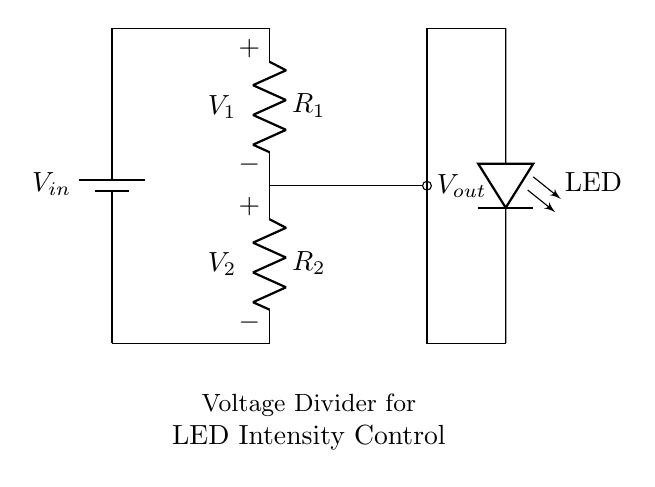What components are in the circuit? The circuit includes a battery, two resistors, and an LED. Each component serves a specific function: the battery provides power, the resistors create a voltage divider, and the LED lights up when a certain voltage is applied.
Answer: battery, two resistors, LED What is the function of the resistors? The resistors R1 and R2 in a voltage divider control the voltage output to the LED by dividing the input voltage. The ratio of their resistances determines the voltage drop across each, which in turn determines the voltage applied to the LED, controlling its brightness.
Answer: control LED voltage What is the voltage across R1? The voltage across R1 is denoted as V1 in the diagram. It is the voltage drop across the first resistor, which contributes to the total input voltage minus the voltage drop across R2.
Answer: V1 What is the purpose of the voltage divider in this circuit? The voltage divider is used to adjust the intensity of the LED stage lighting by controlling the voltage applied to the LED, allowing for dimming effects based on the selected resistor values.
Answer: adjust LED intensity If R1 is twice the value of R2, what happens to Vout? If R1 is twice the value of R2, the voltage output (Vout) will be one-third of the input voltage (Vin) due to the voltage divider rule: Vout = Vin * (R2 / (R1 + R2)), meaning the LED will receive less voltage, resulting in lower brightness.
Answer: Vout = Vin / 3 How does changing R2 affect the LED? Changing the resistance value of R2 alters the voltage drop across it. A lower R2 increases Vout, providing the LED with more voltage, which can lead to higher brightness; conversely, a higher R2 decreases Vout, dimming the LED.
Answer: changes LED brightness 